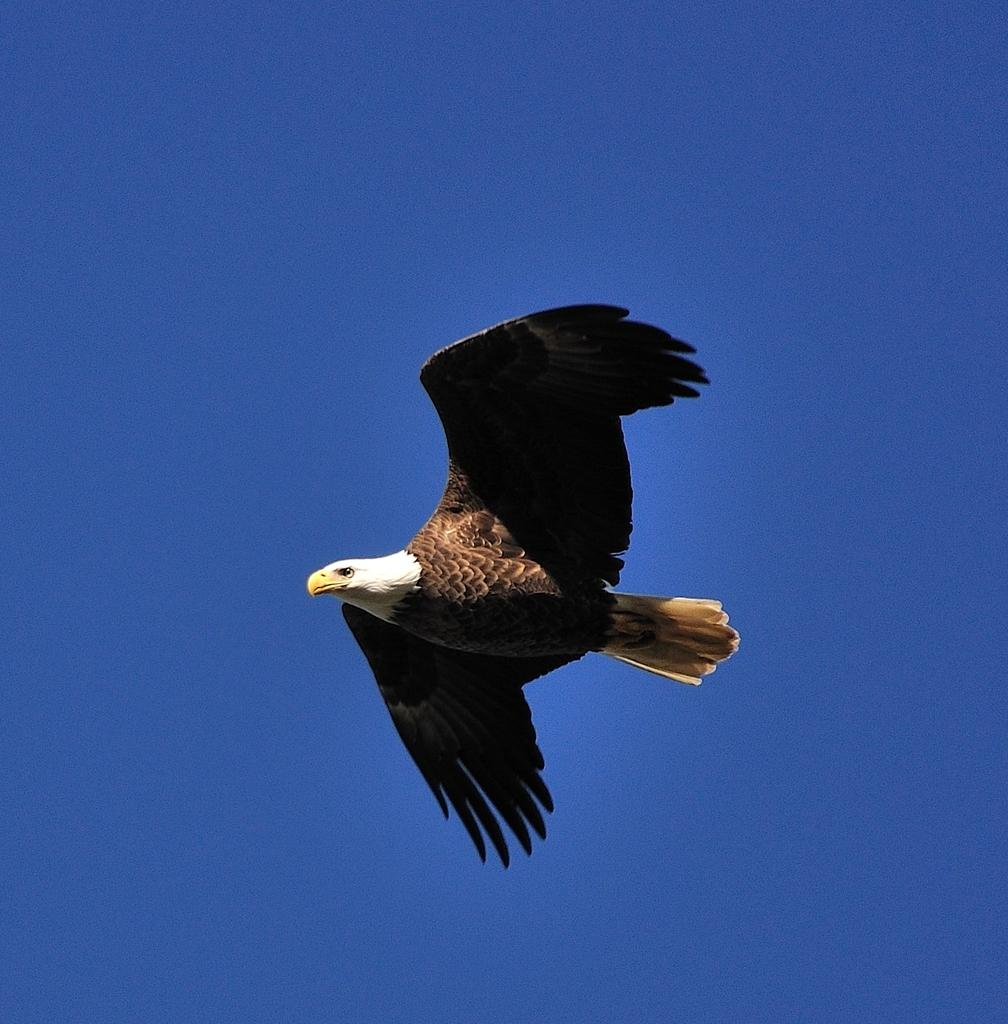What animal can be seen in the image? There is an eagle in the image. What is the eagle doing in the image? The eagle is flying in the sky. What type of whip is the eagle holding in its talons in the image? There is no whip present in the image; the eagle is simply flying in the sky. 